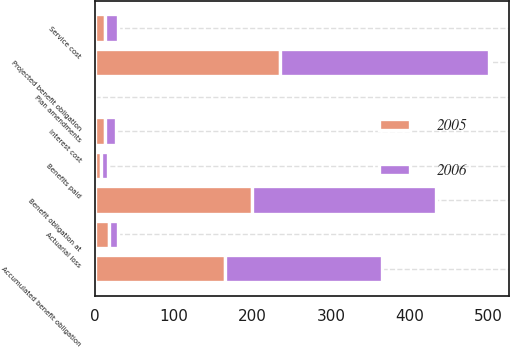Convert chart. <chart><loc_0><loc_0><loc_500><loc_500><stacked_bar_chart><ecel><fcel>Benefit obligation at<fcel>Service cost<fcel>Interest cost<fcel>Plan amendments<fcel>Actuarial loss<fcel>Benefits paid<fcel>Projected benefit obligation<fcel>Accumulated benefit obligation<nl><fcel>2006<fcel>235<fcel>16<fcel>14<fcel>0<fcel>11<fcel>10<fcel>266<fcel>200<nl><fcel>2005<fcel>199<fcel>13<fcel>12<fcel>0<fcel>18<fcel>7<fcel>235<fcel>165<nl></chart> 